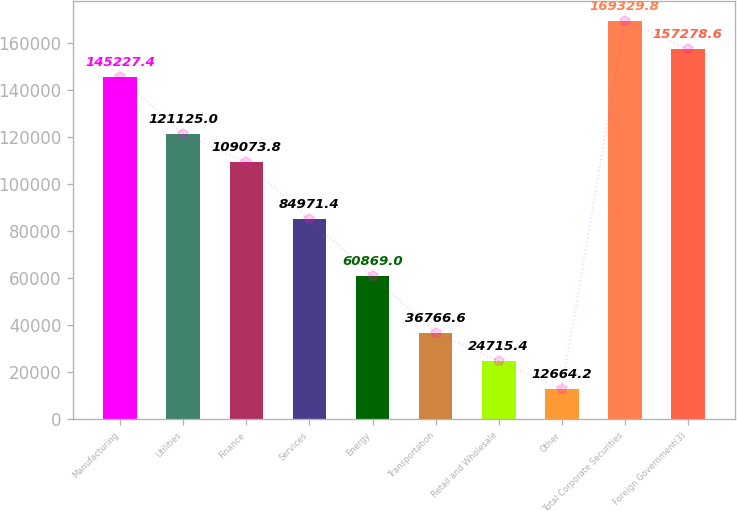Convert chart to OTSL. <chart><loc_0><loc_0><loc_500><loc_500><bar_chart><fcel>Manufacturing<fcel>Utilities<fcel>Finance<fcel>Services<fcel>Energy<fcel>Transportation<fcel>Retail and Wholesale<fcel>Other<fcel>Total Corporate Securities<fcel>Foreign Government(3)<nl><fcel>145227<fcel>121125<fcel>109074<fcel>84971.4<fcel>60869<fcel>36766.6<fcel>24715.4<fcel>12664.2<fcel>169330<fcel>157279<nl></chart> 